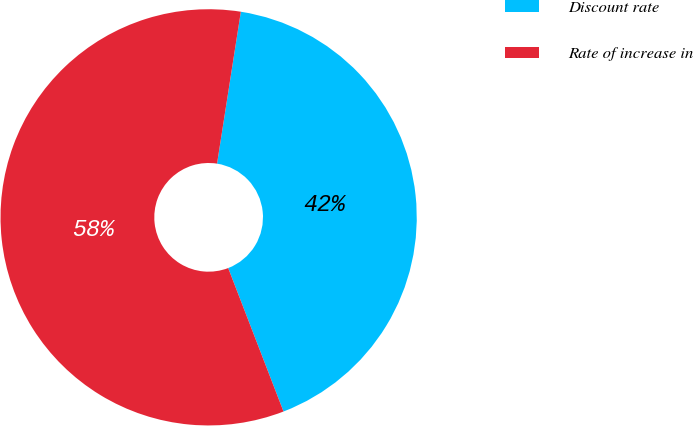<chart> <loc_0><loc_0><loc_500><loc_500><pie_chart><fcel>Discount rate<fcel>Rate of increase in<nl><fcel>41.67%<fcel>58.33%<nl></chart> 